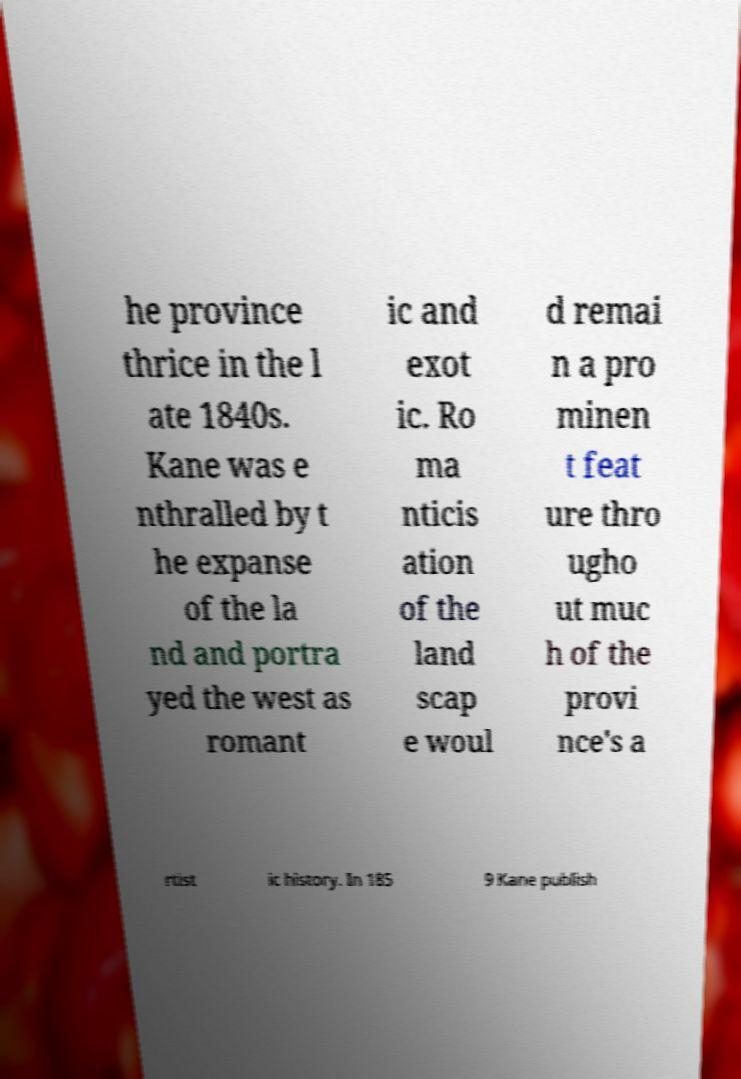Can you accurately transcribe the text from the provided image for me? he province thrice in the l ate 1840s. Kane was e nthralled by t he expanse of the la nd and portra yed the west as romant ic and exot ic. Ro ma nticis ation of the land scap e woul d remai n a pro minen t feat ure thro ugho ut muc h of the provi nce's a rtist ic history. In 185 9 Kane publish 